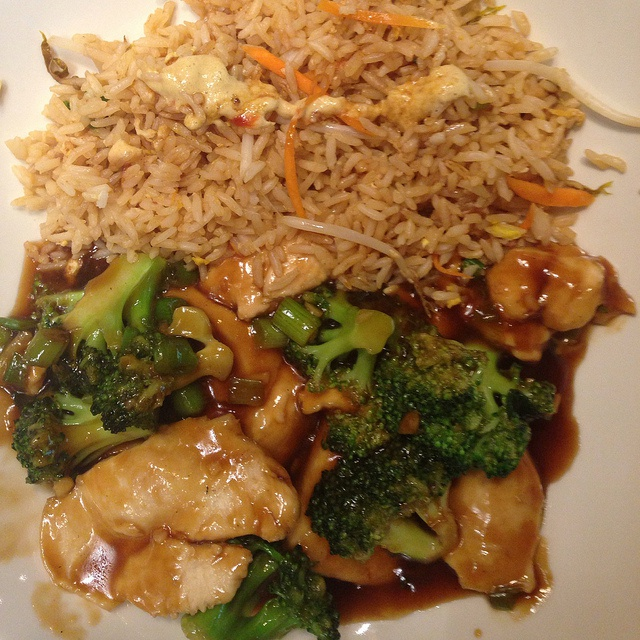Describe the objects in this image and their specific colors. I can see broccoli in lightgray, black, olive, maroon, and darkgreen tones, broccoli in lightgray, olive, black, and maroon tones, broccoli in lightgray, black, darkgreen, and maroon tones, carrot in lightgray, orange, red, and tan tones, and carrot in lightgray, tan, red, and orange tones in this image. 